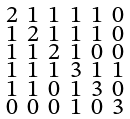Convert formula to latex. <formula><loc_0><loc_0><loc_500><loc_500>\begin{smallmatrix} 2 & 1 & 1 & 1 & 1 & 0 \\ 1 & 2 & 1 & 1 & 1 & 0 \\ 1 & 1 & 2 & 1 & 0 & 0 \\ 1 & 1 & 1 & 3 & 1 & 1 \\ 1 & 1 & 0 & 1 & 3 & 0 \\ 0 & 0 & 0 & 1 & 0 & 3 \end{smallmatrix}</formula> 